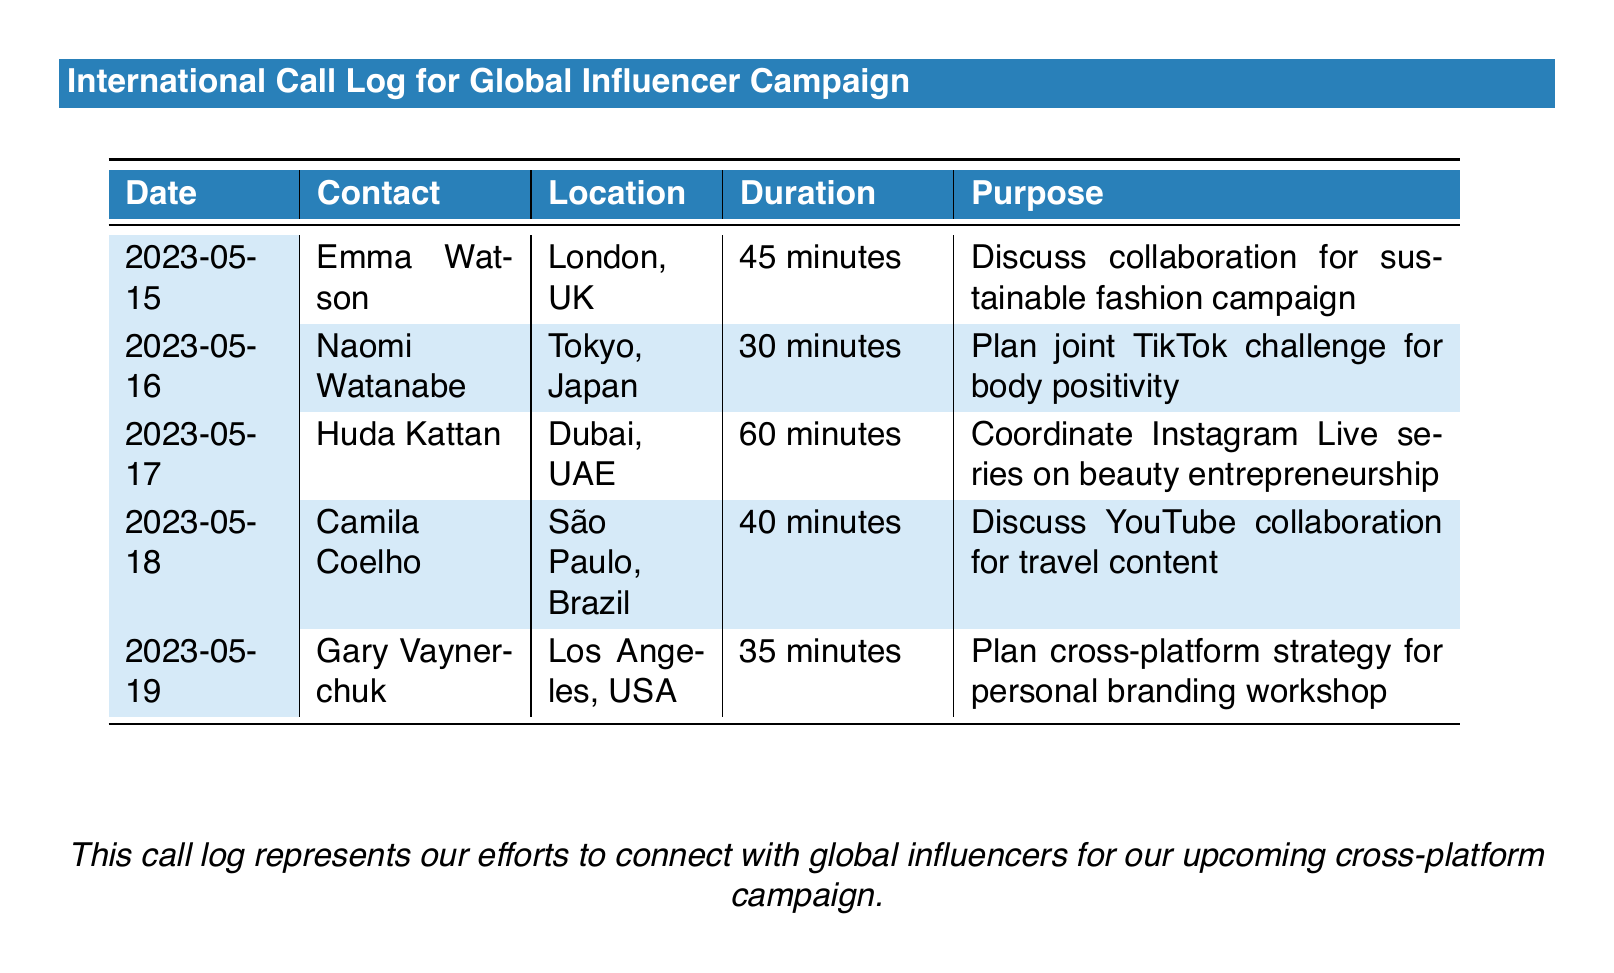What is the date of the first call? The first call in the log occurred on May 15, 2023.
Answer: May 15, 2023 Who is the contact for the call on May 16? The contact for the call on May 16 is Naomi Watanabe.
Answer: Naomi Watanabe Which location is associated with Huda Kattan? Huda Kattan is associated with Dubai, UAE.
Answer: Dubai, UAE What was the purpose of the call with Emma Watson? The purpose of the call with Emma Watson was to discuss collaboration for a sustainable fashion campaign.
Answer: Discuss collaboration for sustainable fashion campaign How long was the call with Gary Vaynerchuk? The call with Gary Vaynerchuk lasted for 35 minutes.
Answer: 35 minutes How many calls were made to contacts in Japan? There was one call made to a contact in Japan.
Answer: One What is the total duration of calls listed in the document? The total duration is calculated by adding the individual durations of all the calls: 45 + 30 + 60 + 40 + 35 = 210 minutes.
Answer: 210 minutes Which influencer was contacted for a TikTok challenge? The influencer contacted for a TikTok challenge was Naomi Watanabe.
Answer: Naomi Watanabe What type of campaign are the calls related to? The calls are related to a cross-platform campaign.
Answer: Cross-platform campaign 